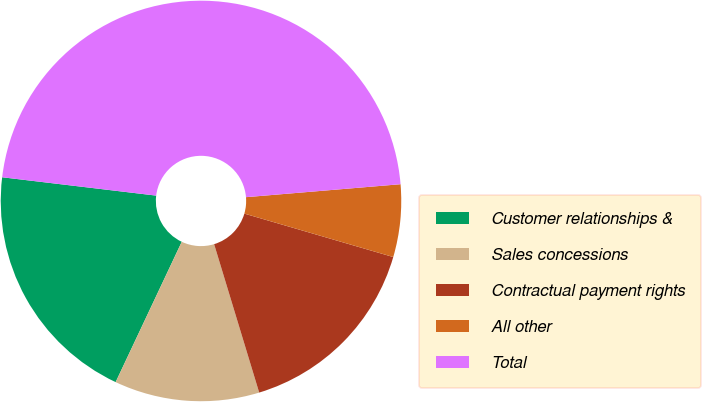Convert chart. <chart><loc_0><loc_0><loc_500><loc_500><pie_chart><fcel>Customer relationships &<fcel>Sales concessions<fcel>Contractual payment rights<fcel>All other<fcel>Total<nl><fcel>19.88%<fcel>11.7%<fcel>15.79%<fcel>5.85%<fcel>46.78%<nl></chart> 